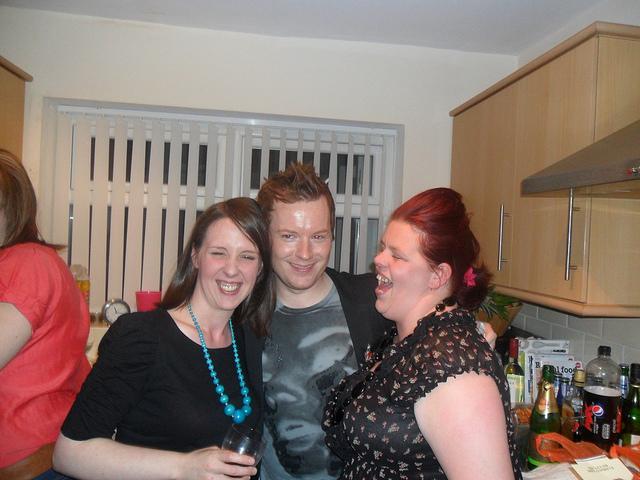How many people have red hair?
Answer briefly. 1. What is the design of the woman's shirt?
Short answer required. Floral. Is the older woman wearing glasses?
Give a very brief answer. No. Is the game in the photo a "Wii" game?
Concise answer only. No. Have the people in this picture used hairspray on their hair tonight?
Write a very short answer. Yes. Are people hungry?
Short answer required. No. What are the people doing?
Quick response, please. Party. Are the people young?
Be succinct. Yes. What pattern appears on the ceiling?
Keep it brief. None. What is this person holding?
Keep it brief. Cup. Is this a party?
Be succinct. Yes. What hand is holding the cup?
Give a very brief answer. Right. How many ladies are wearing a crown?
Answer briefly. 0. Are there people eating?
Keep it brief. No. 